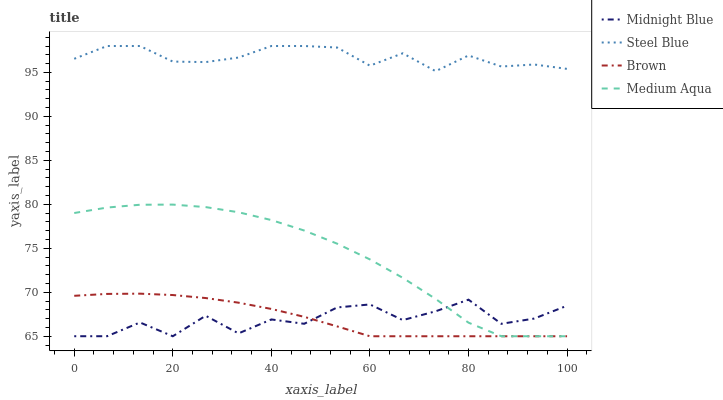Does Midnight Blue have the minimum area under the curve?
Answer yes or no. Yes. Does Steel Blue have the maximum area under the curve?
Answer yes or no. Yes. Does Medium Aqua have the minimum area under the curve?
Answer yes or no. No. Does Medium Aqua have the maximum area under the curve?
Answer yes or no. No. Is Brown the smoothest?
Answer yes or no. Yes. Is Midnight Blue the roughest?
Answer yes or no. Yes. Is Medium Aqua the smoothest?
Answer yes or no. No. Is Medium Aqua the roughest?
Answer yes or no. No. Does Brown have the lowest value?
Answer yes or no. Yes. Does Steel Blue have the lowest value?
Answer yes or no. No. Does Steel Blue have the highest value?
Answer yes or no. Yes. Does Medium Aqua have the highest value?
Answer yes or no. No. Is Midnight Blue less than Steel Blue?
Answer yes or no. Yes. Is Steel Blue greater than Midnight Blue?
Answer yes or no. Yes. Does Brown intersect Medium Aqua?
Answer yes or no. Yes. Is Brown less than Medium Aqua?
Answer yes or no. No. Is Brown greater than Medium Aqua?
Answer yes or no. No. Does Midnight Blue intersect Steel Blue?
Answer yes or no. No. 